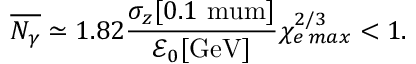Convert formula to latex. <formula><loc_0><loc_0><loc_500><loc_500>\overline { { N _ { \gamma } } } \simeq 1 . 8 2 \frac { \sigma _ { z } [ 0 . 1 \ m u m ] } { \mathcal { E } _ { 0 } [ G e V ] } \chi _ { e \, \max } ^ { 2 / 3 } < 1 .</formula> 